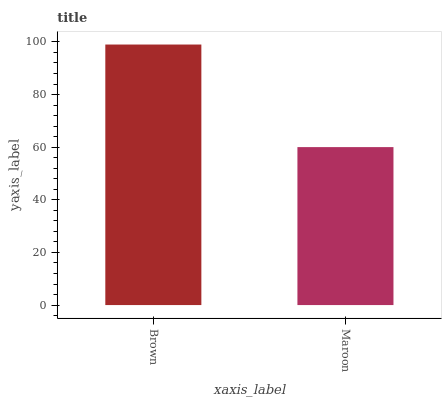Is Maroon the minimum?
Answer yes or no. Yes. Is Brown the maximum?
Answer yes or no. Yes. Is Maroon the maximum?
Answer yes or no. No. Is Brown greater than Maroon?
Answer yes or no. Yes. Is Maroon less than Brown?
Answer yes or no. Yes. Is Maroon greater than Brown?
Answer yes or no. No. Is Brown less than Maroon?
Answer yes or no. No. Is Brown the high median?
Answer yes or no. Yes. Is Maroon the low median?
Answer yes or no. Yes. Is Maroon the high median?
Answer yes or no. No. Is Brown the low median?
Answer yes or no. No. 